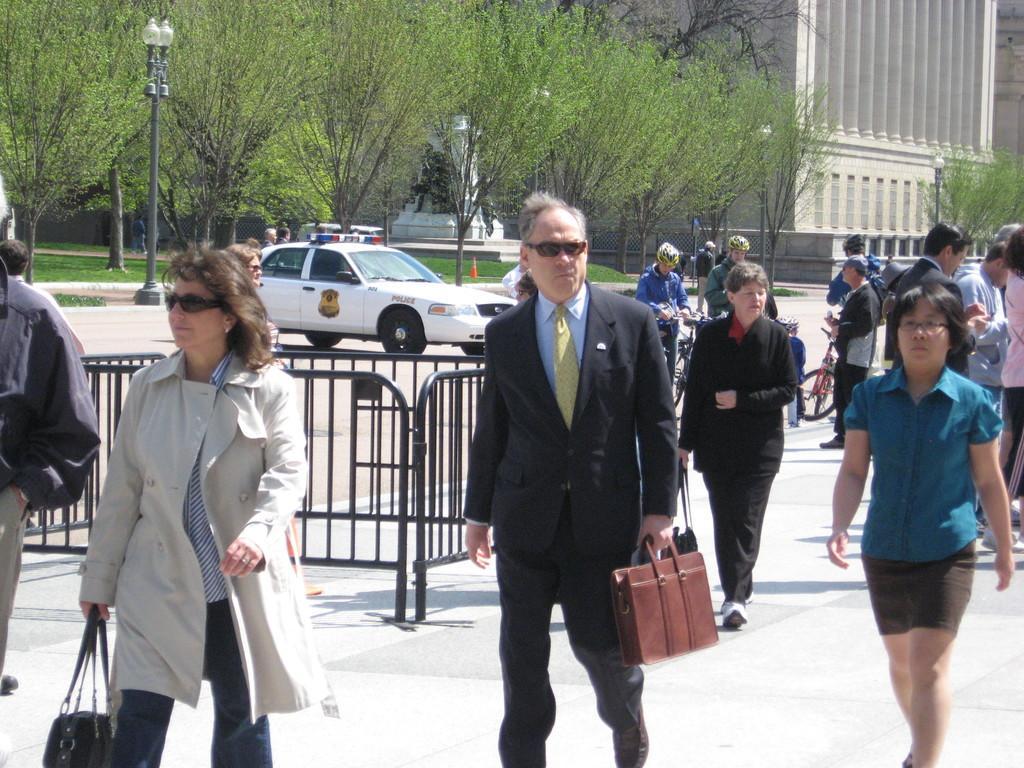Describe this image in one or two sentences. In the middle of the image few people are walking and few people are holding bicycles. Behind them there is fencing. Behind the fencing there is a vehicle on the road. At the top of the image there are some poles and trees and buildings and there is grass. 